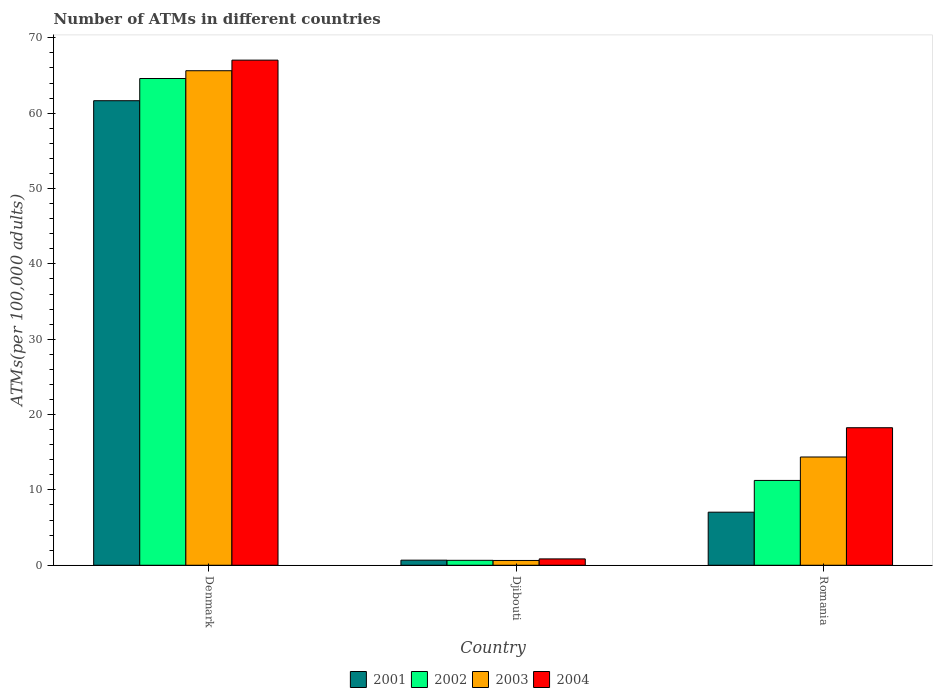How many groups of bars are there?
Give a very brief answer. 3. Are the number of bars on each tick of the X-axis equal?
Offer a very short reply. Yes. What is the label of the 2nd group of bars from the left?
Offer a very short reply. Djibouti. What is the number of ATMs in 2003 in Denmark?
Provide a succinct answer. 65.64. Across all countries, what is the maximum number of ATMs in 2003?
Give a very brief answer. 65.64. Across all countries, what is the minimum number of ATMs in 2004?
Provide a succinct answer. 0.84. In which country was the number of ATMs in 2003 maximum?
Keep it short and to the point. Denmark. In which country was the number of ATMs in 2004 minimum?
Keep it short and to the point. Djibouti. What is the total number of ATMs in 2001 in the graph?
Keep it short and to the point. 69.38. What is the difference between the number of ATMs in 2004 in Denmark and that in Djibouti?
Provide a succinct answer. 66.2. What is the difference between the number of ATMs in 2003 in Denmark and the number of ATMs in 2004 in Romania?
Keep it short and to the point. 47.38. What is the average number of ATMs in 2002 per country?
Ensure brevity in your answer.  25.51. What is the difference between the number of ATMs of/in 2003 and number of ATMs of/in 2002 in Romania?
Your answer should be very brief. 3.11. In how many countries, is the number of ATMs in 2004 greater than 50?
Make the answer very short. 1. What is the ratio of the number of ATMs in 2004 in Denmark to that in Romania?
Make the answer very short. 3.67. Is the number of ATMs in 2002 in Djibouti less than that in Romania?
Your answer should be compact. Yes. Is the difference between the number of ATMs in 2003 in Denmark and Djibouti greater than the difference between the number of ATMs in 2002 in Denmark and Djibouti?
Your response must be concise. Yes. What is the difference between the highest and the second highest number of ATMs in 2001?
Your answer should be compact. -60.98. What is the difference between the highest and the lowest number of ATMs in 2003?
Make the answer very short. 65. Is the sum of the number of ATMs in 2003 in Denmark and Djibouti greater than the maximum number of ATMs in 2001 across all countries?
Your answer should be very brief. Yes. Is it the case that in every country, the sum of the number of ATMs in 2004 and number of ATMs in 2003 is greater than the sum of number of ATMs in 2001 and number of ATMs in 2002?
Your answer should be compact. No. What does the 1st bar from the left in Djibouti represents?
Your response must be concise. 2001. Is it the case that in every country, the sum of the number of ATMs in 2004 and number of ATMs in 2001 is greater than the number of ATMs in 2002?
Make the answer very short. Yes. How many bars are there?
Provide a succinct answer. 12. How many countries are there in the graph?
Your answer should be very brief. 3. What is the difference between two consecutive major ticks on the Y-axis?
Provide a short and direct response. 10. Does the graph contain any zero values?
Provide a succinct answer. No. Does the graph contain grids?
Give a very brief answer. No. Where does the legend appear in the graph?
Give a very brief answer. Bottom center. What is the title of the graph?
Provide a succinct answer. Number of ATMs in different countries. Does "1983" appear as one of the legend labels in the graph?
Ensure brevity in your answer.  No. What is the label or title of the Y-axis?
Make the answer very short. ATMs(per 100,0 adults). What is the ATMs(per 100,000 adults) of 2001 in Denmark?
Ensure brevity in your answer.  61.66. What is the ATMs(per 100,000 adults) of 2002 in Denmark?
Provide a succinct answer. 64.61. What is the ATMs(per 100,000 adults) of 2003 in Denmark?
Your answer should be compact. 65.64. What is the ATMs(per 100,000 adults) of 2004 in Denmark?
Provide a short and direct response. 67.04. What is the ATMs(per 100,000 adults) in 2001 in Djibouti?
Keep it short and to the point. 0.68. What is the ATMs(per 100,000 adults) in 2002 in Djibouti?
Your answer should be compact. 0.66. What is the ATMs(per 100,000 adults) of 2003 in Djibouti?
Offer a very short reply. 0.64. What is the ATMs(per 100,000 adults) of 2004 in Djibouti?
Offer a terse response. 0.84. What is the ATMs(per 100,000 adults) in 2001 in Romania?
Provide a succinct answer. 7.04. What is the ATMs(per 100,000 adults) in 2002 in Romania?
Your answer should be compact. 11.26. What is the ATMs(per 100,000 adults) of 2003 in Romania?
Your answer should be compact. 14.37. What is the ATMs(per 100,000 adults) of 2004 in Romania?
Your answer should be very brief. 18.26. Across all countries, what is the maximum ATMs(per 100,000 adults) in 2001?
Your response must be concise. 61.66. Across all countries, what is the maximum ATMs(per 100,000 adults) in 2002?
Offer a very short reply. 64.61. Across all countries, what is the maximum ATMs(per 100,000 adults) of 2003?
Ensure brevity in your answer.  65.64. Across all countries, what is the maximum ATMs(per 100,000 adults) of 2004?
Provide a succinct answer. 67.04. Across all countries, what is the minimum ATMs(per 100,000 adults) of 2001?
Make the answer very short. 0.68. Across all countries, what is the minimum ATMs(per 100,000 adults) of 2002?
Make the answer very short. 0.66. Across all countries, what is the minimum ATMs(per 100,000 adults) in 2003?
Keep it short and to the point. 0.64. Across all countries, what is the minimum ATMs(per 100,000 adults) in 2004?
Provide a short and direct response. 0.84. What is the total ATMs(per 100,000 adults) of 2001 in the graph?
Your response must be concise. 69.38. What is the total ATMs(per 100,000 adults) in 2002 in the graph?
Ensure brevity in your answer.  76.52. What is the total ATMs(per 100,000 adults) of 2003 in the graph?
Keep it short and to the point. 80.65. What is the total ATMs(per 100,000 adults) in 2004 in the graph?
Ensure brevity in your answer.  86.14. What is the difference between the ATMs(per 100,000 adults) in 2001 in Denmark and that in Djibouti?
Offer a terse response. 60.98. What is the difference between the ATMs(per 100,000 adults) of 2002 in Denmark and that in Djibouti?
Your answer should be very brief. 63.95. What is the difference between the ATMs(per 100,000 adults) of 2003 in Denmark and that in Djibouti?
Your response must be concise. 65. What is the difference between the ATMs(per 100,000 adults) of 2004 in Denmark and that in Djibouti?
Your answer should be compact. 66.2. What is the difference between the ATMs(per 100,000 adults) of 2001 in Denmark and that in Romania?
Ensure brevity in your answer.  54.61. What is the difference between the ATMs(per 100,000 adults) in 2002 in Denmark and that in Romania?
Ensure brevity in your answer.  53.35. What is the difference between the ATMs(per 100,000 adults) of 2003 in Denmark and that in Romania?
Offer a very short reply. 51.27. What is the difference between the ATMs(per 100,000 adults) of 2004 in Denmark and that in Romania?
Offer a very short reply. 48.79. What is the difference between the ATMs(per 100,000 adults) in 2001 in Djibouti and that in Romania?
Give a very brief answer. -6.37. What is the difference between the ATMs(per 100,000 adults) of 2002 in Djibouti and that in Romania?
Make the answer very short. -10.6. What is the difference between the ATMs(per 100,000 adults) of 2003 in Djibouti and that in Romania?
Offer a very short reply. -13.73. What is the difference between the ATMs(per 100,000 adults) in 2004 in Djibouti and that in Romania?
Offer a very short reply. -17.41. What is the difference between the ATMs(per 100,000 adults) of 2001 in Denmark and the ATMs(per 100,000 adults) of 2002 in Djibouti?
Make the answer very short. 61. What is the difference between the ATMs(per 100,000 adults) of 2001 in Denmark and the ATMs(per 100,000 adults) of 2003 in Djibouti?
Provide a succinct answer. 61.02. What is the difference between the ATMs(per 100,000 adults) of 2001 in Denmark and the ATMs(per 100,000 adults) of 2004 in Djibouti?
Make the answer very short. 60.81. What is the difference between the ATMs(per 100,000 adults) in 2002 in Denmark and the ATMs(per 100,000 adults) in 2003 in Djibouti?
Make the answer very short. 63.97. What is the difference between the ATMs(per 100,000 adults) in 2002 in Denmark and the ATMs(per 100,000 adults) in 2004 in Djibouti?
Your answer should be very brief. 63.76. What is the difference between the ATMs(per 100,000 adults) of 2003 in Denmark and the ATMs(per 100,000 adults) of 2004 in Djibouti?
Offer a terse response. 64.79. What is the difference between the ATMs(per 100,000 adults) in 2001 in Denmark and the ATMs(per 100,000 adults) in 2002 in Romania?
Make the answer very short. 50.4. What is the difference between the ATMs(per 100,000 adults) of 2001 in Denmark and the ATMs(per 100,000 adults) of 2003 in Romania?
Your response must be concise. 47.29. What is the difference between the ATMs(per 100,000 adults) of 2001 in Denmark and the ATMs(per 100,000 adults) of 2004 in Romania?
Ensure brevity in your answer.  43.4. What is the difference between the ATMs(per 100,000 adults) of 2002 in Denmark and the ATMs(per 100,000 adults) of 2003 in Romania?
Your answer should be compact. 50.24. What is the difference between the ATMs(per 100,000 adults) in 2002 in Denmark and the ATMs(per 100,000 adults) in 2004 in Romania?
Offer a very short reply. 46.35. What is the difference between the ATMs(per 100,000 adults) of 2003 in Denmark and the ATMs(per 100,000 adults) of 2004 in Romania?
Make the answer very short. 47.38. What is the difference between the ATMs(per 100,000 adults) of 2001 in Djibouti and the ATMs(per 100,000 adults) of 2002 in Romania?
Offer a very short reply. -10.58. What is the difference between the ATMs(per 100,000 adults) of 2001 in Djibouti and the ATMs(per 100,000 adults) of 2003 in Romania?
Ensure brevity in your answer.  -13.69. What is the difference between the ATMs(per 100,000 adults) of 2001 in Djibouti and the ATMs(per 100,000 adults) of 2004 in Romania?
Give a very brief answer. -17.58. What is the difference between the ATMs(per 100,000 adults) in 2002 in Djibouti and the ATMs(per 100,000 adults) in 2003 in Romania?
Your response must be concise. -13.71. What is the difference between the ATMs(per 100,000 adults) of 2002 in Djibouti and the ATMs(per 100,000 adults) of 2004 in Romania?
Provide a short and direct response. -17.6. What is the difference between the ATMs(per 100,000 adults) in 2003 in Djibouti and the ATMs(per 100,000 adults) in 2004 in Romania?
Give a very brief answer. -17.62. What is the average ATMs(per 100,000 adults) in 2001 per country?
Give a very brief answer. 23.13. What is the average ATMs(per 100,000 adults) of 2002 per country?
Keep it short and to the point. 25.51. What is the average ATMs(per 100,000 adults) of 2003 per country?
Give a very brief answer. 26.88. What is the average ATMs(per 100,000 adults) in 2004 per country?
Give a very brief answer. 28.71. What is the difference between the ATMs(per 100,000 adults) of 2001 and ATMs(per 100,000 adults) of 2002 in Denmark?
Ensure brevity in your answer.  -2.95. What is the difference between the ATMs(per 100,000 adults) in 2001 and ATMs(per 100,000 adults) in 2003 in Denmark?
Give a very brief answer. -3.98. What is the difference between the ATMs(per 100,000 adults) of 2001 and ATMs(per 100,000 adults) of 2004 in Denmark?
Give a very brief answer. -5.39. What is the difference between the ATMs(per 100,000 adults) of 2002 and ATMs(per 100,000 adults) of 2003 in Denmark?
Your answer should be compact. -1.03. What is the difference between the ATMs(per 100,000 adults) in 2002 and ATMs(per 100,000 adults) in 2004 in Denmark?
Your answer should be compact. -2.44. What is the difference between the ATMs(per 100,000 adults) of 2003 and ATMs(per 100,000 adults) of 2004 in Denmark?
Offer a very short reply. -1.41. What is the difference between the ATMs(per 100,000 adults) in 2001 and ATMs(per 100,000 adults) in 2002 in Djibouti?
Provide a succinct answer. 0.02. What is the difference between the ATMs(per 100,000 adults) in 2001 and ATMs(per 100,000 adults) in 2003 in Djibouti?
Give a very brief answer. 0.04. What is the difference between the ATMs(per 100,000 adults) in 2001 and ATMs(per 100,000 adults) in 2004 in Djibouti?
Offer a very short reply. -0.17. What is the difference between the ATMs(per 100,000 adults) in 2002 and ATMs(per 100,000 adults) in 2003 in Djibouti?
Keep it short and to the point. 0.02. What is the difference between the ATMs(per 100,000 adults) in 2002 and ATMs(per 100,000 adults) in 2004 in Djibouti?
Provide a short and direct response. -0.19. What is the difference between the ATMs(per 100,000 adults) of 2003 and ATMs(per 100,000 adults) of 2004 in Djibouti?
Offer a terse response. -0.21. What is the difference between the ATMs(per 100,000 adults) in 2001 and ATMs(per 100,000 adults) in 2002 in Romania?
Give a very brief answer. -4.21. What is the difference between the ATMs(per 100,000 adults) in 2001 and ATMs(per 100,000 adults) in 2003 in Romania?
Your answer should be compact. -7.32. What is the difference between the ATMs(per 100,000 adults) in 2001 and ATMs(per 100,000 adults) in 2004 in Romania?
Keep it short and to the point. -11.21. What is the difference between the ATMs(per 100,000 adults) of 2002 and ATMs(per 100,000 adults) of 2003 in Romania?
Give a very brief answer. -3.11. What is the difference between the ATMs(per 100,000 adults) in 2002 and ATMs(per 100,000 adults) in 2004 in Romania?
Make the answer very short. -7. What is the difference between the ATMs(per 100,000 adults) of 2003 and ATMs(per 100,000 adults) of 2004 in Romania?
Give a very brief answer. -3.89. What is the ratio of the ATMs(per 100,000 adults) of 2001 in Denmark to that in Djibouti?
Offer a very short reply. 91.18. What is the ratio of the ATMs(per 100,000 adults) of 2002 in Denmark to that in Djibouti?
Ensure brevity in your answer.  98.45. What is the ratio of the ATMs(per 100,000 adults) of 2003 in Denmark to that in Djibouti?
Give a very brief answer. 102.88. What is the ratio of the ATMs(per 100,000 adults) of 2004 in Denmark to that in Djibouti?
Keep it short and to the point. 79.46. What is the ratio of the ATMs(per 100,000 adults) of 2001 in Denmark to that in Romania?
Give a very brief answer. 8.75. What is the ratio of the ATMs(per 100,000 adults) of 2002 in Denmark to that in Romania?
Ensure brevity in your answer.  5.74. What is the ratio of the ATMs(per 100,000 adults) in 2003 in Denmark to that in Romania?
Keep it short and to the point. 4.57. What is the ratio of the ATMs(per 100,000 adults) in 2004 in Denmark to that in Romania?
Offer a very short reply. 3.67. What is the ratio of the ATMs(per 100,000 adults) in 2001 in Djibouti to that in Romania?
Ensure brevity in your answer.  0.1. What is the ratio of the ATMs(per 100,000 adults) of 2002 in Djibouti to that in Romania?
Your response must be concise. 0.06. What is the ratio of the ATMs(per 100,000 adults) of 2003 in Djibouti to that in Romania?
Your response must be concise. 0.04. What is the ratio of the ATMs(per 100,000 adults) of 2004 in Djibouti to that in Romania?
Your answer should be very brief. 0.05. What is the difference between the highest and the second highest ATMs(per 100,000 adults) in 2001?
Give a very brief answer. 54.61. What is the difference between the highest and the second highest ATMs(per 100,000 adults) in 2002?
Provide a succinct answer. 53.35. What is the difference between the highest and the second highest ATMs(per 100,000 adults) in 2003?
Ensure brevity in your answer.  51.27. What is the difference between the highest and the second highest ATMs(per 100,000 adults) of 2004?
Provide a short and direct response. 48.79. What is the difference between the highest and the lowest ATMs(per 100,000 adults) of 2001?
Your answer should be very brief. 60.98. What is the difference between the highest and the lowest ATMs(per 100,000 adults) in 2002?
Keep it short and to the point. 63.95. What is the difference between the highest and the lowest ATMs(per 100,000 adults) of 2003?
Offer a very short reply. 65. What is the difference between the highest and the lowest ATMs(per 100,000 adults) in 2004?
Your answer should be very brief. 66.2. 